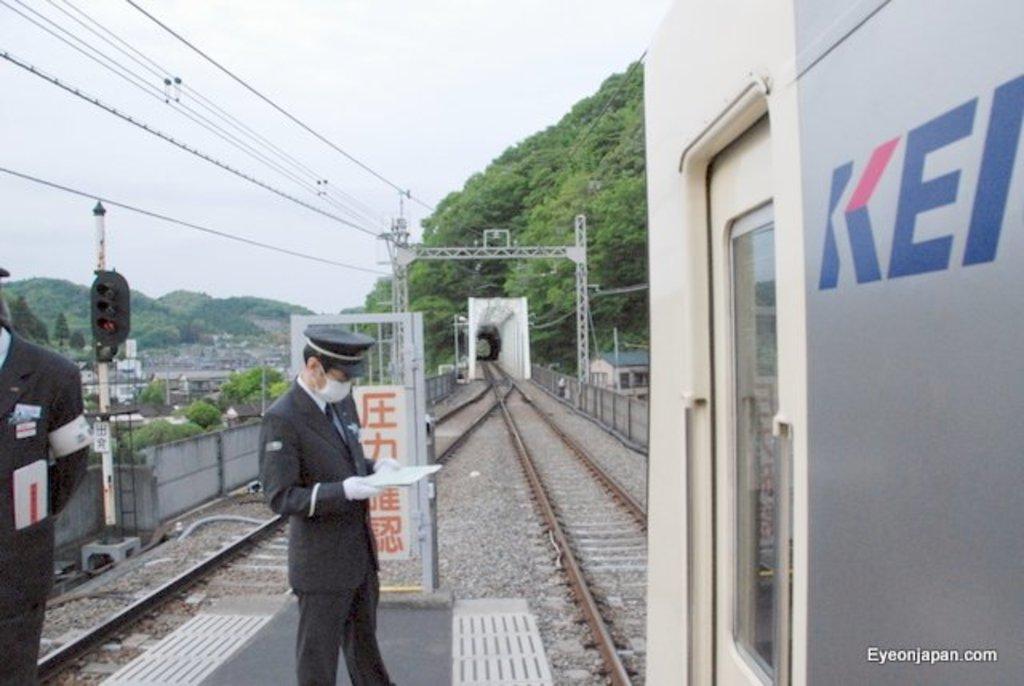Could you give a brief overview of what you see in this image? In this image there are some train tracks and train on it, beside that there are two people standing also there are mountains, buildings and some poles. 